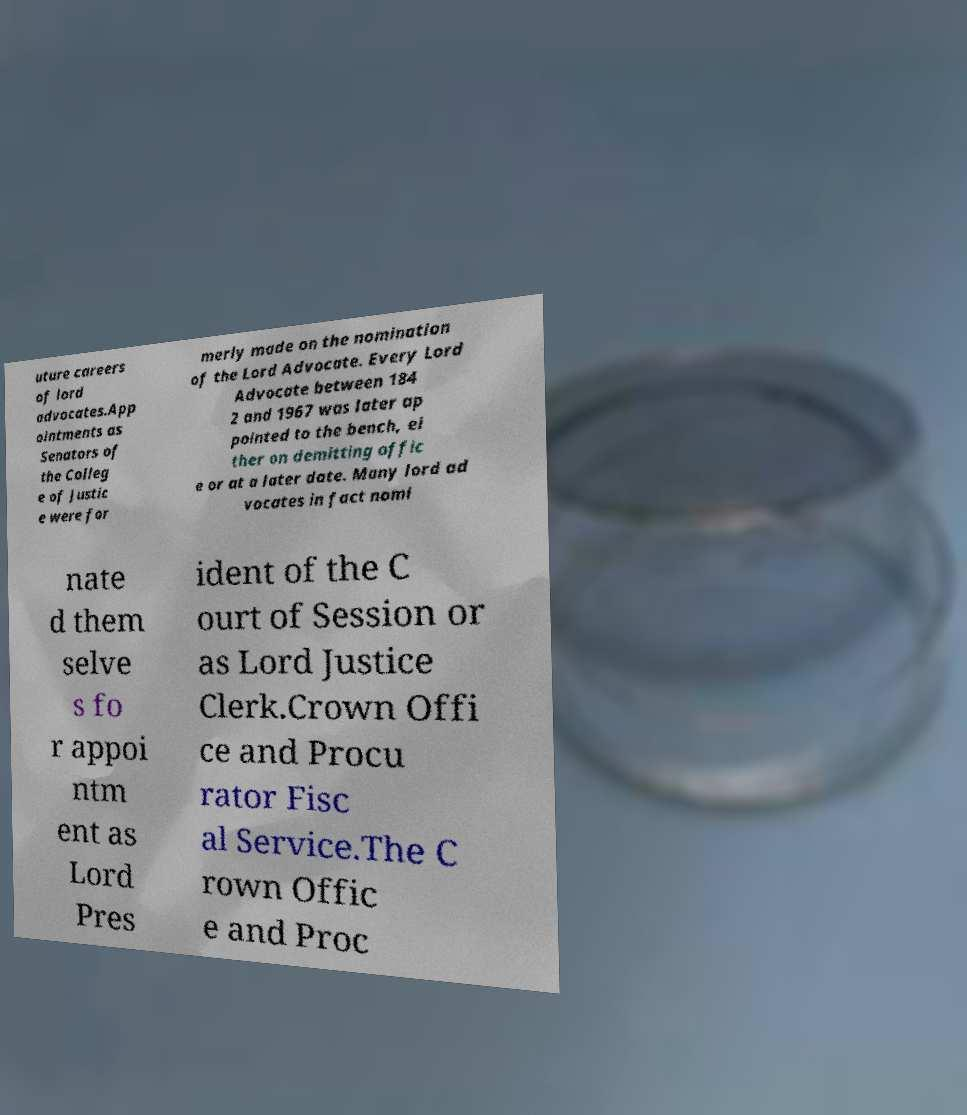What messages or text are displayed in this image? I need them in a readable, typed format. uture careers of lord advocates.App ointments as Senators of the Colleg e of Justic e were for merly made on the nomination of the Lord Advocate. Every Lord Advocate between 184 2 and 1967 was later ap pointed to the bench, ei ther on demitting offic e or at a later date. Many lord ad vocates in fact nomi nate d them selve s fo r appoi ntm ent as Lord Pres ident of the C ourt of Session or as Lord Justice Clerk.Crown Offi ce and Procu rator Fisc al Service.The C rown Offic e and Proc 